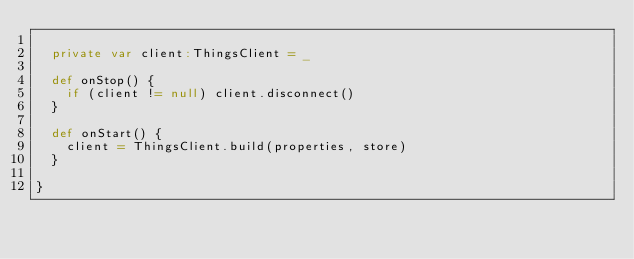<code> <loc_0><loc_0><loc_500><loc_500><_Scala_>
  private var client:ThingsClient = _

  def onStop() {
    if (client != null) client.disconnect()
  }

  def onStart() {
    client = ThingsClient.build(properties, store)
  }

}</code> 